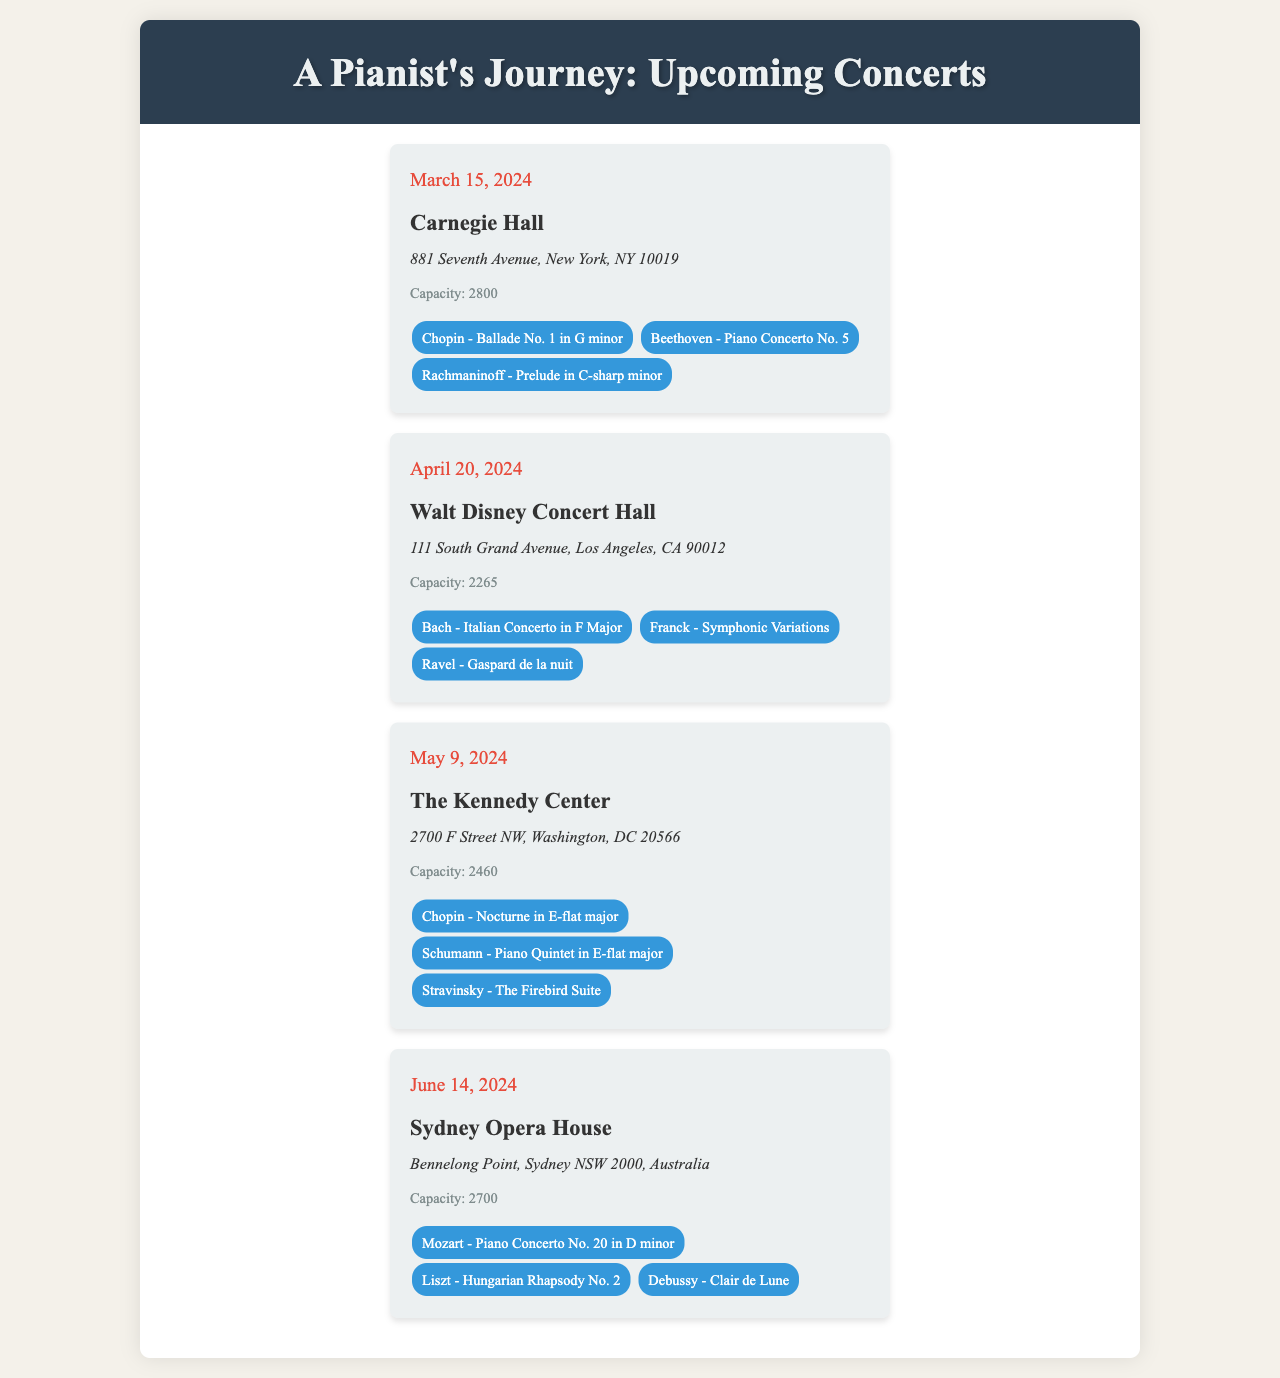What is the date of the concert at Carnegie Hall? The date of the concert at Carnegie Hall is stated in the document as March 15, 2024.
Answer: March 15, 2024 What is the capacity of Walt Disney Concert Hall? The document specifies that the capacity of Walt Disney Concert Hall is 2265.
Answer: 2265 Which repertoire includes a piece by Rachmaninoff? By reviewing the document, the concert at Carnegie Hall features a piece by Rachmaninoff, specifically the Prelude in C-sharp minor.
Answer: Prelude in C-sharp minor What is the venue for the concert on June 14, 2024? The document indicates that the venue for the concert on June 14, 2024, is the Sydney Opera House.
Answer: Sydney Opera House How many concerts are scheduled in the document? By counting the listed concerts in the document, there are four concerts scheduled.
Answer: Four Which concert features a work by Debussy? The concert at the Sydney Opera House features a work by Debussy, specifically Clair de Lune.
Answer: Clair de Lune What city is The Kennedy Center located in? The document states that The Kennedy Center is located in Washington, DC.
Answer: Washington, DC What is the repertoire for the concert on May 9, 2024? The document lists the repertoire for the concert on May 9, 2024, which includes Chopin's Nocturne in E-flat major, Schumann's Piano Quintet in E-flat major, and Stravinsky's The Firebird Suite.
Answer: Chopin - Nocturne in E-flat major, Schumann - Piano Quintet in E-flat major, Stravinsky - The Firebird Suite 